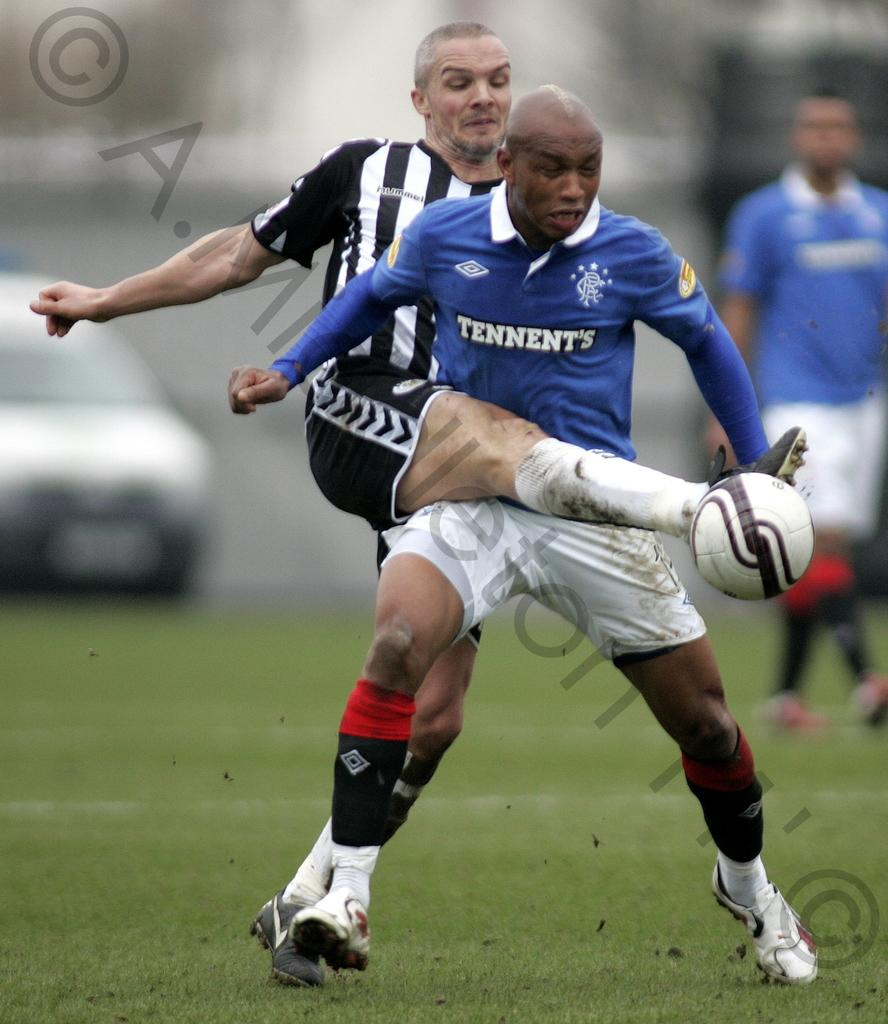What is the main action being performed by the person in the image? There is a person running in the image. What is the other person doing in the image? The other person is hitting a ball in the image. What object is present on the ground in the image? There is a car on the ground in the image. What type of zinc can be seen in the image? There is no zinc present in the image. Is there a monkey visible in the image? No, there is no monkey present in the image. 